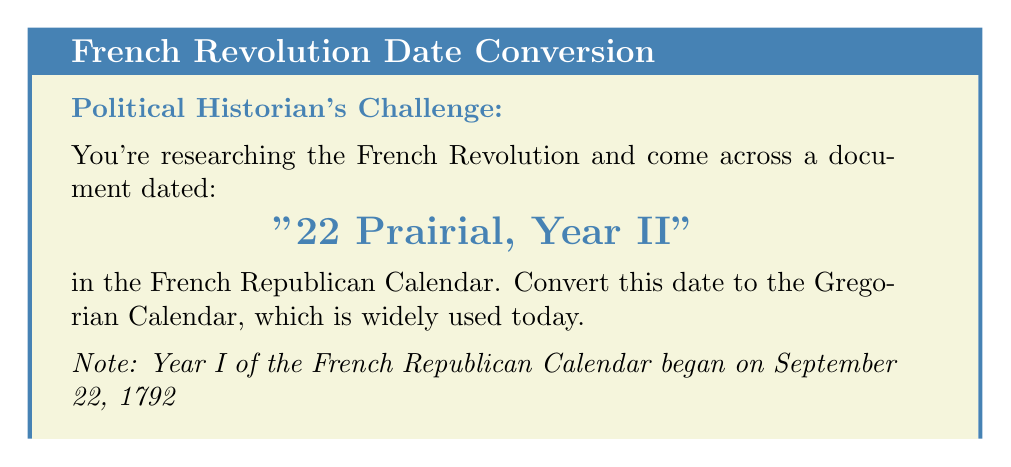What is the answer to this math problem? Let's approach this step-by-step:

1) First, we need to understand the French Republican Calendar:
   - It started on September 22, 1792 (Year I)
   - Each year had 12 months of 30 days each
   - Prairial was the 9th month

2) Calculate the year:
   - Year II corresponds to 1793-1794 in the Gregorian Calendar
   
3) Calculate the number of days from the start of the year:
   - 8 full months have passed: $8 \times 30 = 240$ days
   - Plus 22 days into Prairial: $240 + 22 = 262$ days

4) Calculate the corresponding Gregorian date:
   - Start with September 22, 1793 (beginning of Year II)
   - Add 262 days

5) Perform the addition:
   $$\text{September 22, 1793} + 262 \text{ days} = \text{June 10, 1794}$$

   This calculation can be verified using the following method:
   - September has 8 remaining days: 262 - 8 = 254
   - October has 31 days: 254 - 31 = 223
   - November has 30 days: 223 - 30 = 193
   - December has 31 days: 193 - 31 = 162
   - January has 31 days: 162 - 31 = 131
   - February has 28 days (1794 was not a leap year): 131 - 28 = 103
   - March has 31 days: 103 - 31 = 72
   - April has 30 days: 72 - 30 = 42
   - May has 31 days: 42 - 31 = 11
   - The remaining 11 days bring us to June 10
Answer: June 10, 1794 